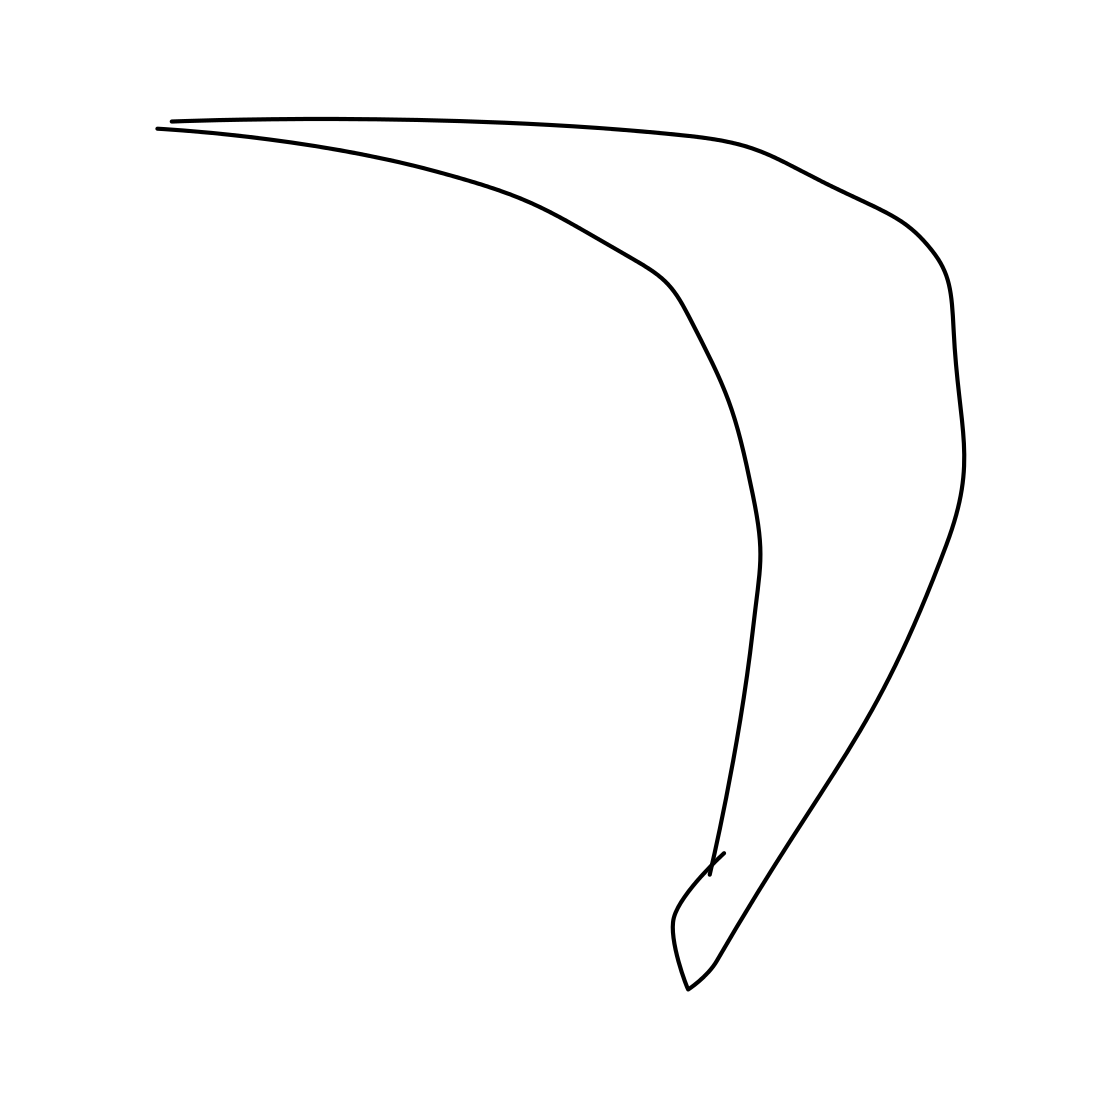How might an artist use such a simple curve in a composition? An artist might use such a simple curve to create a focal point that directs the viewer's eye across the artwork. This kind of curve can add a sense of dynamics and fluidity, often used to break the monotony of straight lines and rigid forms in a piece. Could this curve be part of a larger piece, potentially? Absolutely, this curve could be part of a larger composition, possibly interacting with other elements or shapes to form a more complex image. It could serve as a base or contrast to highlight other features within the artwork. 